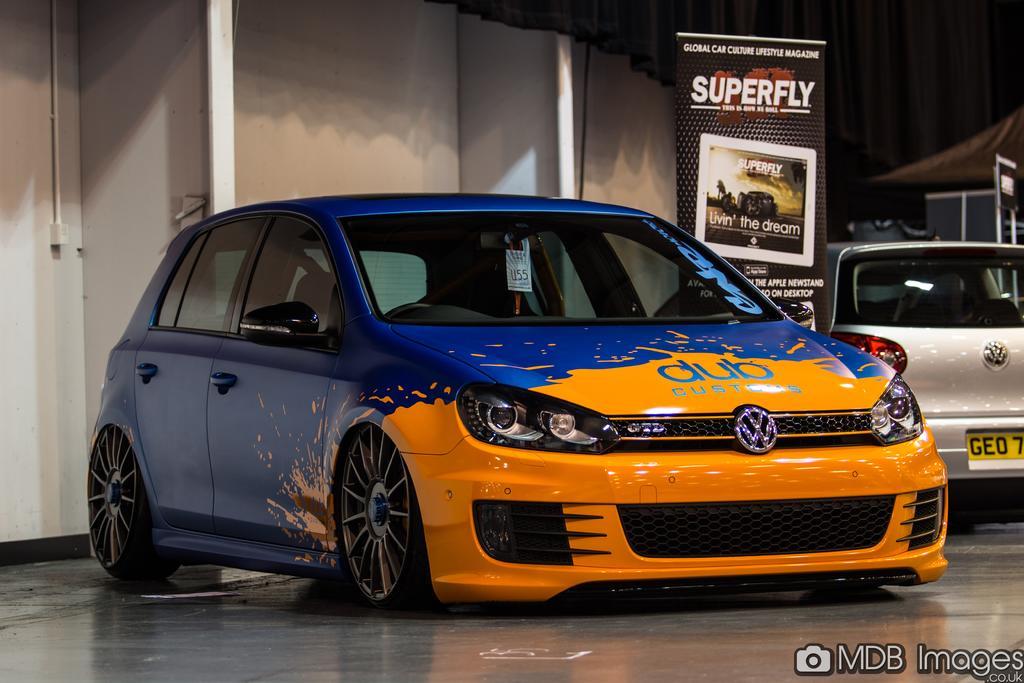Describe this image in one or two sentences. In this image we can see cars on the floor and there is a hoarding. In the background we can see wall. At the bottom of the image we can see a watermark. 